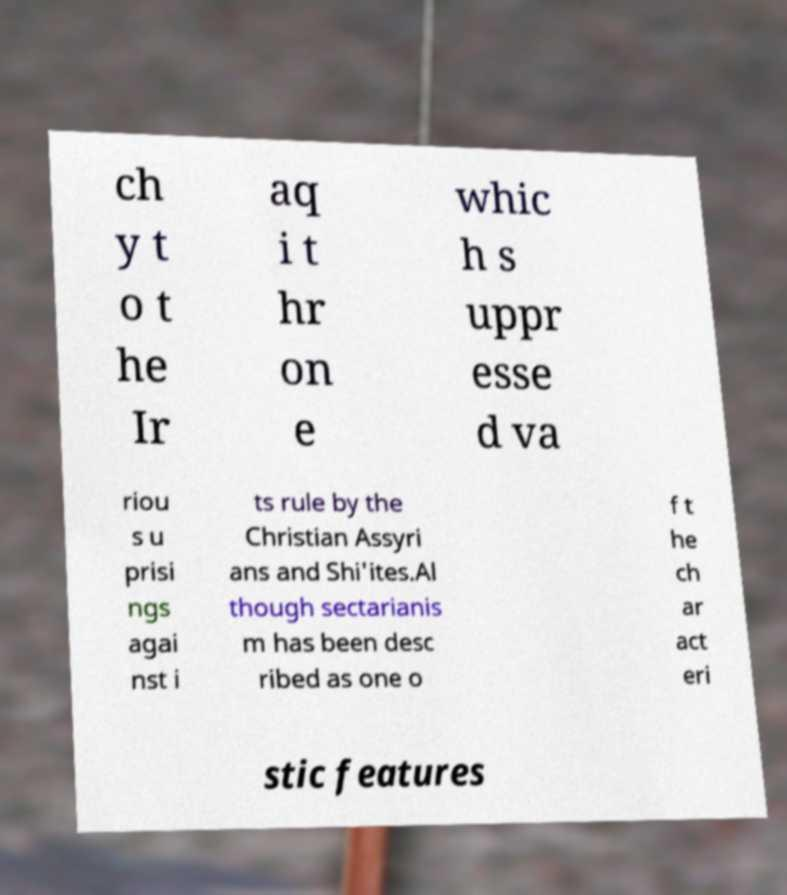Please read and relay the text visible in this image. What does it say? ch y t o t he Ir aq i t hr on e whic h s uppr esse d va riou s u prisi ngs agai nst i ts rule by the Christian Assyri ans and Shi'ites.Al though sectarianis m has been desc ribed as one o f t he ch ar act eri stic features 